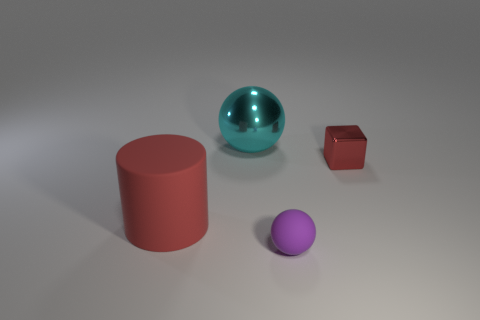There is a rubber thing that is on the right side of the rubber cylinder; is its size the same as the big metallic sphere?
Your answer should be very brief. No. What number of red things are small things or blocks?
Your answer should be very brief. 1. What is the material of the thing in front of the rubber cylinder?
Make the answer very short. Rubber. How many red matte objects are in front of the sphere that is in front of the small block?
Make the answer very short. 0. What number of large metal objects have the same shape as the purple matte thing?
Your response must be concise. 1. What number of shiny objects are there?
Your response must be concise. 2. What is the color of the ball that is behind the red rubber cylinder?
Ensure brevity in your answer.  Cyan. There is a big thing that is to the right of the red thing left of the cyan metallic sphere; what is its color?
Give a very brief answer. Cyan. There is a metallic thing that is the same size as the rubber cylinder; what is its color?
Provide a short and direct response. Cyan. What number of objects are both left of the purple matte thing and right of the tiny purple sphere?
Your response must be concise. 0. 